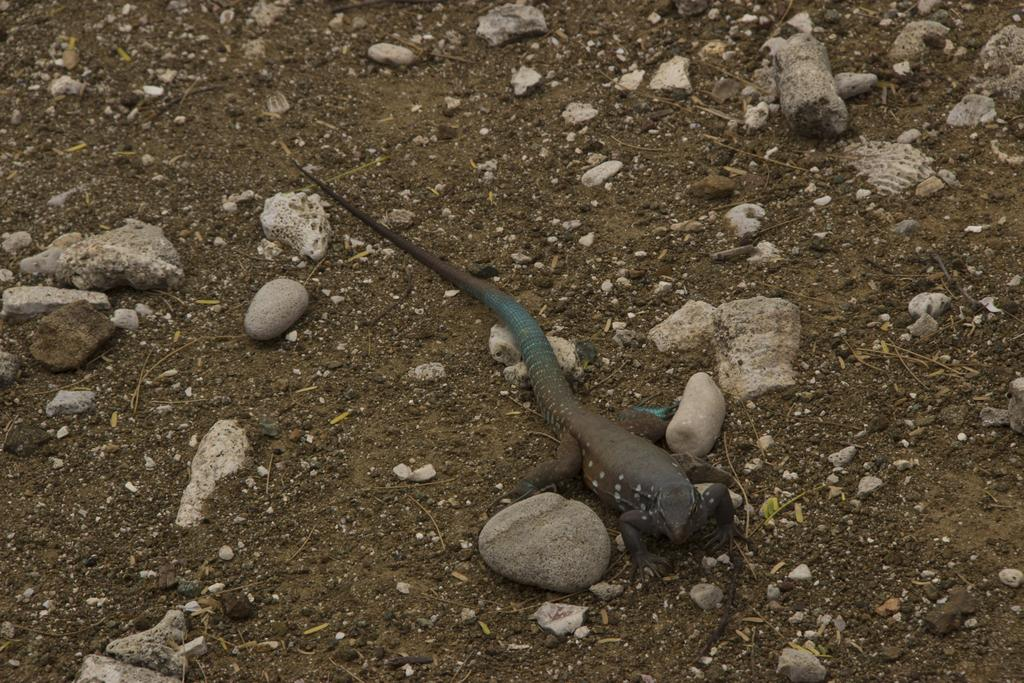What type of animal is in the image? There is a reptile in the image. Where is the reptile located in relation to the stones? The reptile is between stones. What can be seen in the background of the image? There is land visible in the background of the image. What is present on the land in the background? There are stones present on the land in the background. What type of wrench is the reptile using to compete in the image? There is no wrench or competition present in the image; it features a reptile between stones with land visible in the background. 